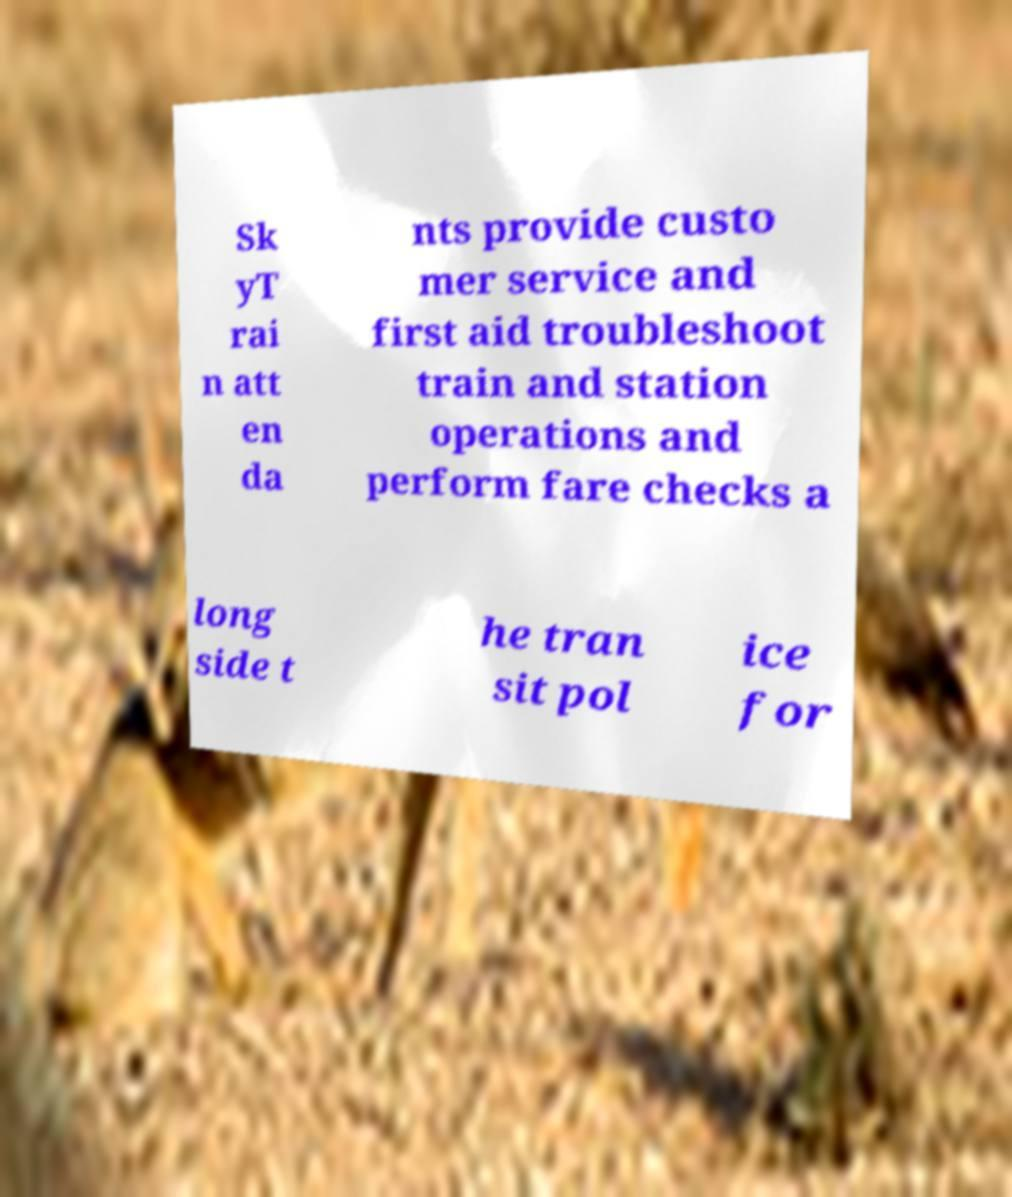Please read and relay the text visible in this image. What does it say? Sk yT rai n att en da nts provide custo mer service and first aid troubleshoot train and station operations and perform fare checks a long side t he tran sit pol ice for 